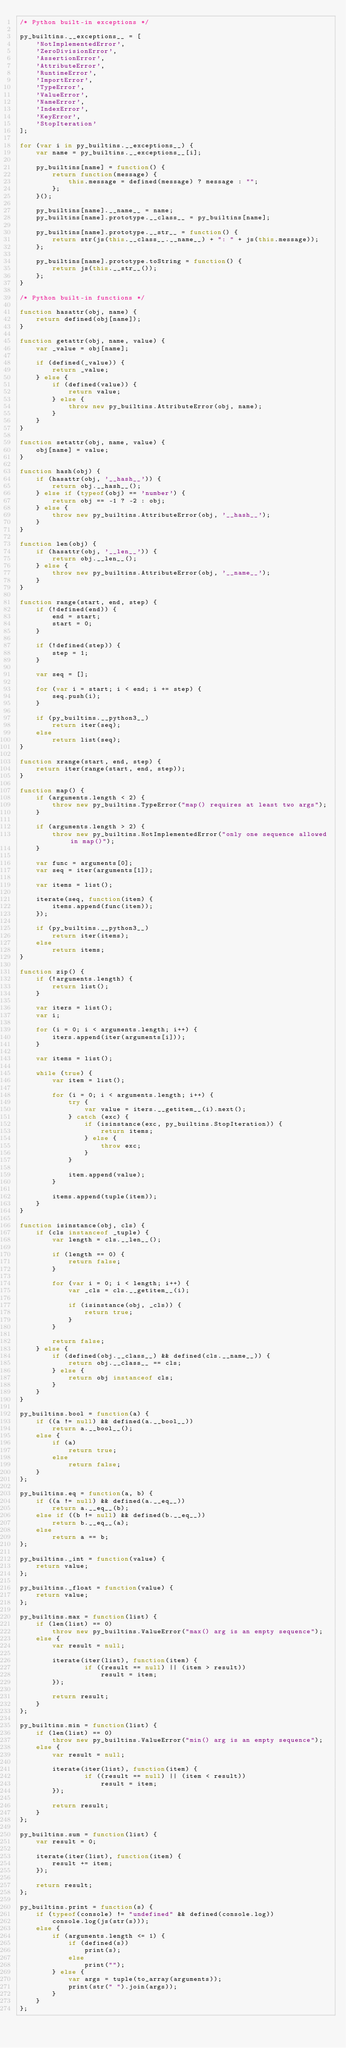Convert code to text. <code><loc_0><loc_0><loc_500><loc_500><_JavaScript_>/* Python built-in exceptions */

py_builtins.__exceptions__ = [
    'NotImplementedError',
    'ZeroDivisionError',
    'AssertionError',
    'AttributeError',
    'RuntimeError',
    'ImportError',
    'TypeError',
    'ValueError',
    'NameError',
    'IndexError',
    'KeyError',
    'StopIteration'
];

for (var i in py_builtins.__exceptions__) {
    var name = py_builtins.__exceptions__[i];

    py_builtins[name] = function() {
        return function(message) {
            this.message = defined(message) ? message : "";
        };
    }();

    py_builtins[name].__name__ = name;
    py_builtins[name].prototype.__class__ = py_builtins[name];

    py_builtins[name].prototype.__str__ = function() {
        return str(js(this.__class__.__name__) + ": " + js(this.message));
    };

    py_builtins[name].prototype.toString = function() {
        return js(this.__str__());
    };
}

/* Python built-in functions */

function hasattr(obj, name) {
    return defined(obj[name]);
}

function getattr(obj, name, value) {
    var _value = obj[name];

    if (defined(_value)) {
        return _value;
    } else {
        if (defined(value)) {
            return value;
        } else {
            throw new py_builtins.AttributeError(obj, name);
        }
    }
}

function setattr(obj, name, value) {
    obj[name] = value;
}

function hash(obj) {
    if (hasattr(obj, '__hash__')) {
        return obj.__hash__();
    } else if (typeof(obj) == 'number') {
        return obj == -1 ? -2 : obj;
    } else {
        throw new py_builtins.AttributeError(obj, '__hash__');
    }
}

function len(obj) {
    if (hasattr(obj, '__len__')) {
        return obj.__len__();
    } else {
        throw new py_builtins.AttributeError(obj, '__name__');
    }
}

function range(start, end, step) {
    if (!defined(end)) {
        end = start;
        start = 0;
    }

    if (!defined(step)) {
        step = 1;
    }

    var seq = [];

    for (var i = start; i < end; i += step) {
        seq.push(i);
    }

    if (py_builtins.__python3__)
        return iter(seq);
    else
        return list(seq);
}

function xrange(start, end, step) {
    return iter(range(start, end, step));
}

function map() {
    if (arguments.length < 2) {
        throw new py_builtins.TypeError("map() requires at least two args");
    }

    if (arguments.length > 2) {
        throw new py_builtins.NotImplementedError("only one sequence allowed in map()");
    }

    var func = arguments[0];
    var seq = iter(arguments[1]);

    var items = list();

    iterate(seq, function(item) {
        items.append(func(item));
    });

    if (py_builtins.__python3__)
        return iter(items);
    else
        return items;
}

function zip() {
    if (!arguments.length) {
        return list();
    }

    var iters = list();
    var i;

    for (i = 0; i < arguments.length; i++) {
        iters.append(iter(arguments[i]));
    }

    var items = list();

    while (true) {
        var item = list();

        for (i = 0; i < arguments.length; i++) {
            try {
                var value = iters.__getitem__(i).next();
            } catch (exc) {
                if (isinstance(exc, py_builtins.StopIteration)) {
                    return items;
                } else {
                    throw exc;
                }
            }

            item.append(value);
        }

        items.append(tuple(item));
    }
}

function isinstance(obj, cls) {
    if (cls instanceof _tuple) {
        var length = cls.__len__();

        if (length == 0) {
            return false;
        }

        for (var i = 0; i < length; i++) {
            var _cls = cls.__getitem__(i);

            if (isinstance(obj, _cls)) {
                return true;
            }
        }

        return false;
    } else {
        if (defined(obj.__class__) && defined(cls.__name__)) {
            return obj.__class__ == cls;
        } else {
            return obj instanceof cls;
        }
    }
}

py_builtins.bool = function(a) {
    if ((a != null) && defined(a.__bool__))
        return a.__bool__();
    else {
        if (a)
            return true;
        else
            return false;
    }
};

py_builtins.eq = function(a, b) {
    if ((a != null) && defined(a.__eq__))
        return a.__eq__(b);
    else if ((b != null) && defined(b.__eq__))
        return b.__eq__(a);
    else
        return a == b;
};

py_builtins._int = function(value) {
    return value;
};

py_builtins._float = function(value) {
    return value;
};

py_builtins.max = function(list) {
    if (len(list) == 0)
        throw new py_builtins.ValueError("max() arg is an empty sequence");
    else {
        var result = null;

        iterate(iter(list), function(item) {
                if ((result == null) || (item > result))
                    result = item;
        });

        return result;
    }
};

py_builtins.min = function(list) {
    if (len(list) == 0)
        throw new py_builtins.ValueError("min() arg is an empty sequence");
    else {
        var result = null;

        iterate(iter(list), function(item) {
                if ((result == null) || (item < result))
                    result = item;
        });

        return result;
    }
};

py_builtins.sum = function(list) {
    var result = 0;

    iterate(iter(list), function(item) {
        result += item;
    });

    return result;
};

py_builtins.print = function(s) {
    if (typeof(console) != "undefined" && defined(console.log))
        console.log(js(str(s)));
    else {
        if (arguments.length <= 1) {
            if (defined(s))
                print(s);
            else
                print("");
        } else {
            var args = tuple(to_array(arguments));
            print(str(" ").join(args));
        }
    }
};

</code> 